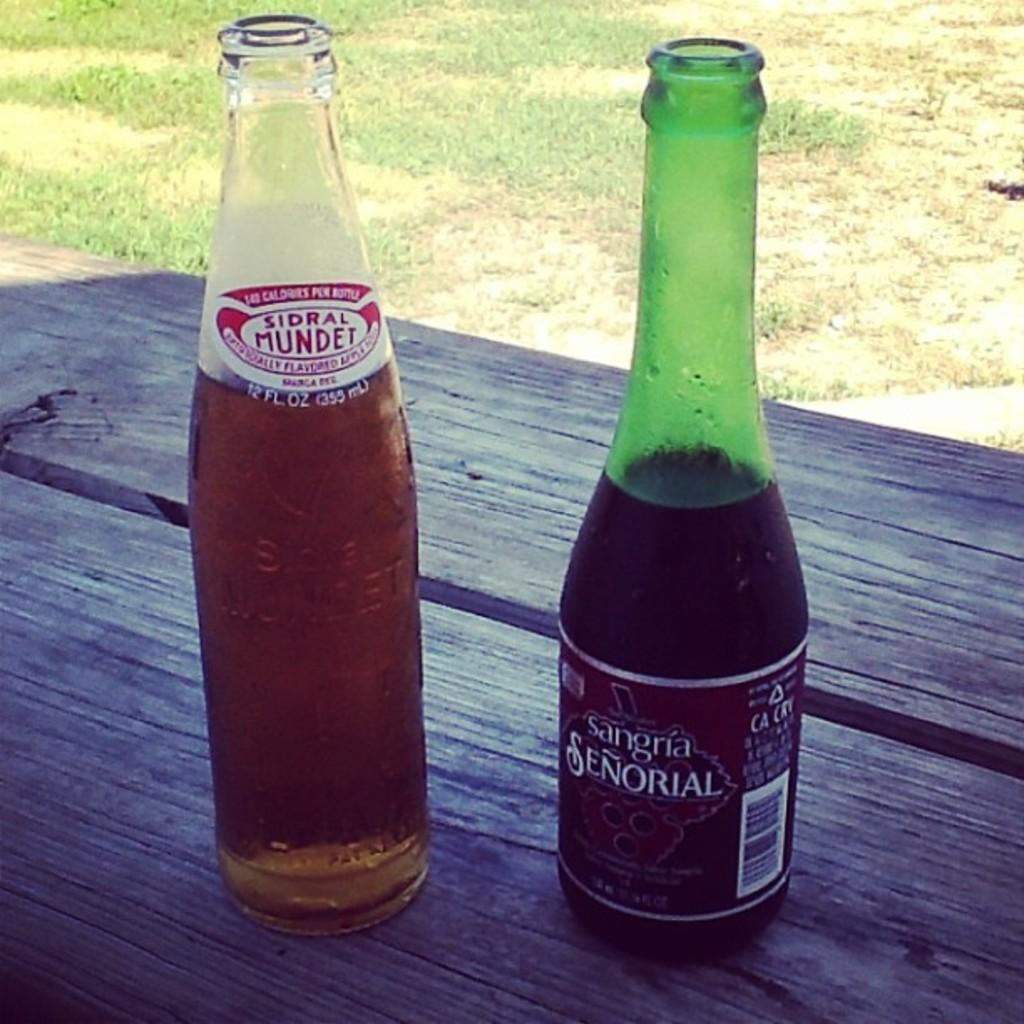<image>
Describe the image concisely. Bottle with a label that says Senorial on it. 